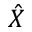<formula> <loc_0><loc_0><loc_500><loc_500>\hat { X }</formula> 